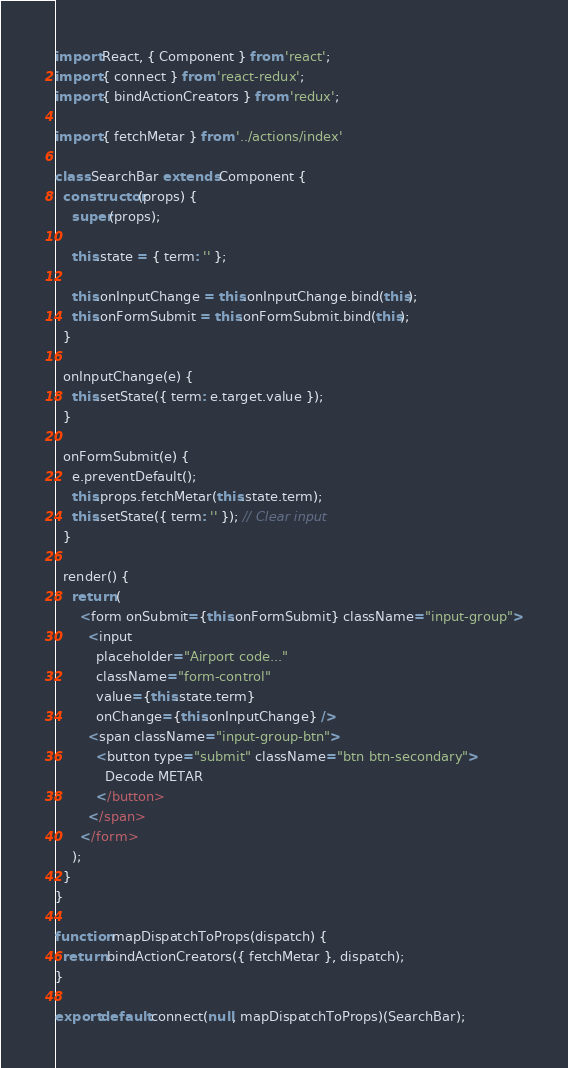Convert code to text. <code><loc_0><loc_0><loc_500><loc_500><_JavaScript_>import React, { Component } from 'react';
import { connect } from 'react-redux';
import { bindActionCreators } from 'redux';

import { fetchMetar } from '../actions/index'

class SearchBar extends Component {
  constructor(props) {
    super(props);

    this.state = { term: '' };

    this.onInputChange = this.onInputChange.bind(this);
    this.onFormSubmit = this.onFormSubmit.bind(this);
  }

  onInputChange(e) {
    this.setState({ term: e.target.value });
  }

  onFormSubmit(e) {
    e.preventDefault();
    this.props.fetchMetar(this.state.term);
    this.setState({ term: '' }); // Clear input
  }

  render() {
    return (
      <form onSubmit={this.onFormSubmit} className="input-group">
        <input
          placeholder="Airport code..."
          className="form-control"
          value={this.state.term}
          onChange={this.onInputChange} />
        <span className="input-group-btn">
          <button type="submit" className="btn btn-secondary">
            Decode METAR
          </button>
        </span>
      </form>
    );
  }
}

function mapDispatchToProps(dispatch) {
  return bindActionCreators({ fetchMetar }, dispatch);
}

export default connect(null, mapDispatchToProps)(SearchBar);
</code> 